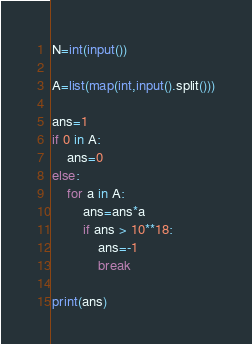<code> <loc_0><loc_0><loc_500><loc_500><_Python_>N=int(input())

A=list(map(int,input().split()))

ans=1
if 0 in A:
    ans=0
else:
    for a in A:
        ans=ans*a
        if ans > 10**18:
            ans=-1
            break

print(ans)
</code> 